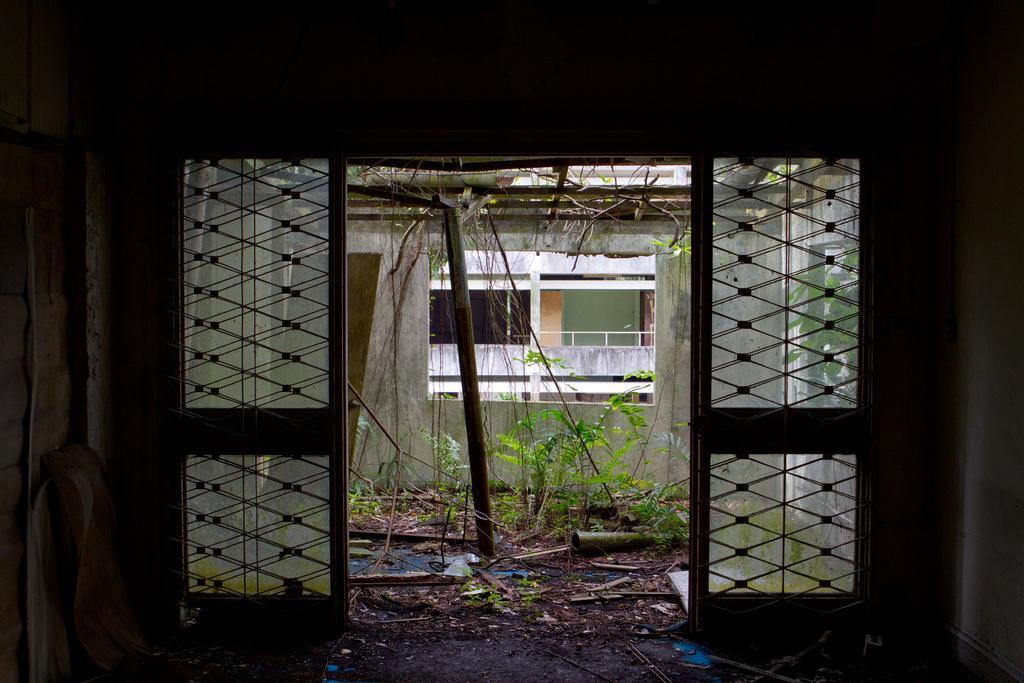How would you summarize this image in a sentence or two? This image is taken in an old house, where there is a glass doors, wall and few sheets leaning to the wall. In the background, there are plants, rods, a pipe on the ground and also we can see a wall, a cardboard sheet leaning to the wall, creepers and a building in the background. 